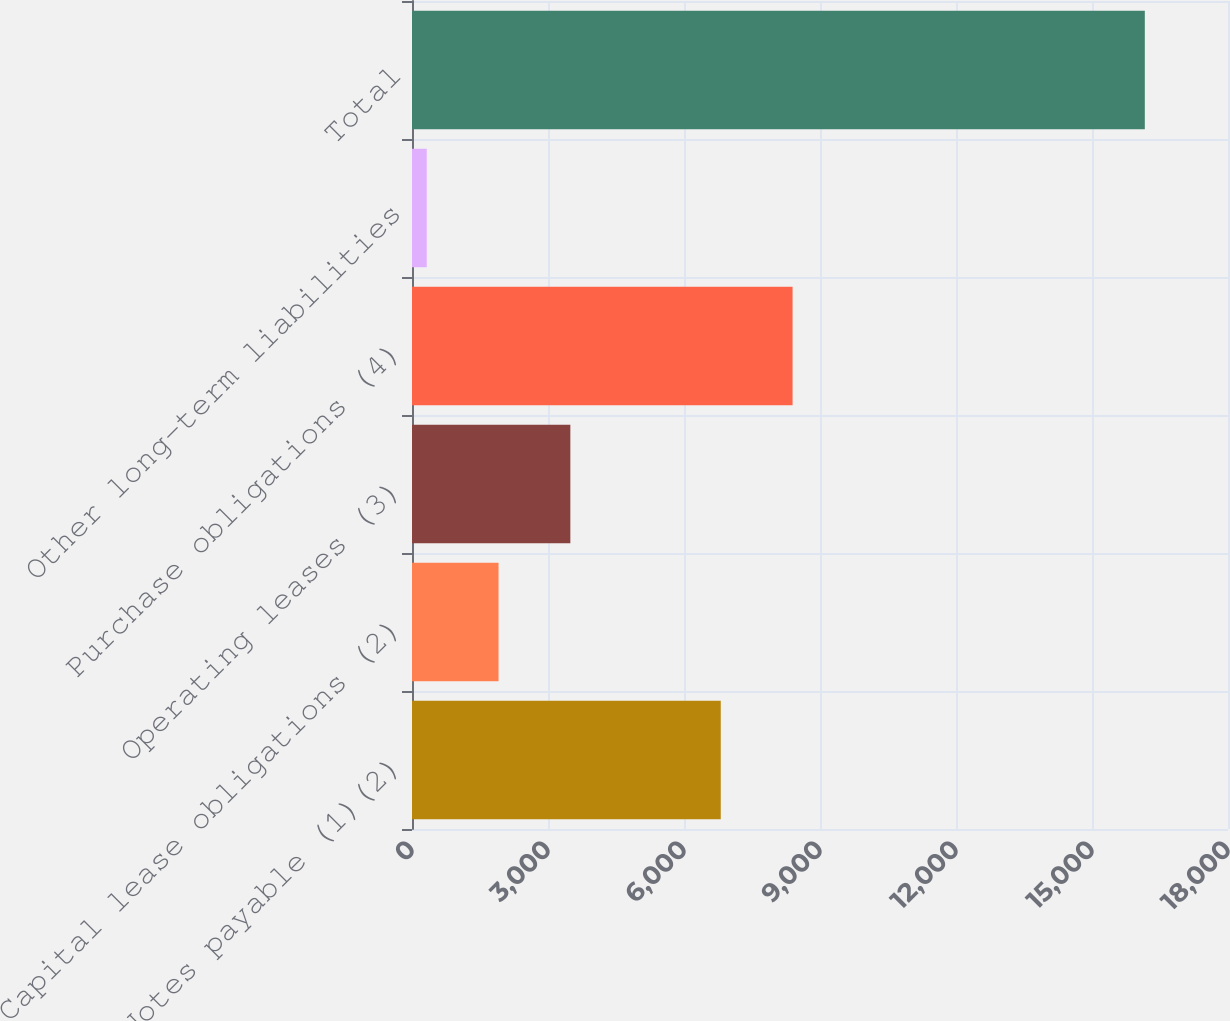Convert chart to OTSL. <chart><loc_0><loc_0><loc_500><loc_500><bar_chart><fcel>Notes payable (1)(2)<fcel>Capital lease obligations (2)<fcel>Operating leases (3)<fcel>Purchase obligations (4)<fcel>Other long-term liabilities<fcel>Total<nl><fcel>6811<fcel>1909<fcel>3493<fcel>8395<fcel>325<fcel>16165<nl></chart> 